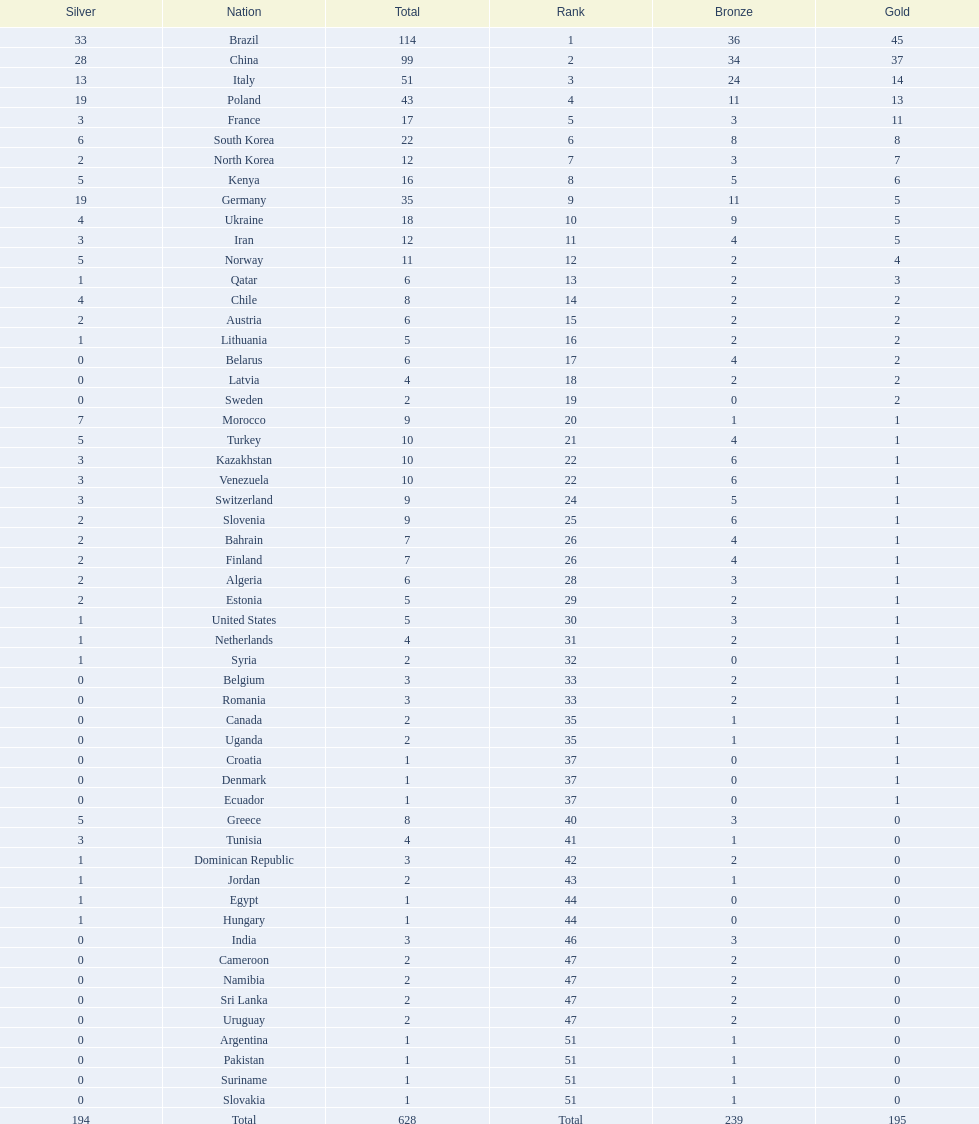Could you parse the entire table? {'header': ['Silver', 'Nation', 'Total', 'Rank', 'Bronze', 'Gold'], 'rows': [['33', 'Brazil', '114', '1', '36', '45'], ['28', 'China', '99', '2', '34', '37'], ['13', 'Italy', '51', '3', '24', '14'], ['19', 'Poland', '43', '4', '11', '13'], ['3', 'France', '17', '5', '3', '11'], ['6', 'South Korea', '22', '6', '8', '8'], ['2', 'North Korea', '12', '7', '3', '7'], ['5', 'Kenya', '16', '8', '5', '6'], ['19', 'Germany', '35', '9', '11', '5'], ['4', 'Ukraine', '18', '10', '9', '5'], ['3', 'Iran', '12', '11', '4', '5'], ['5', 'Norway', '11', '12', '2', '4'], ['1', 'Qatar', '6', '13', '2', '3'], ['4', 'Chile', '8', '14', '2', '2'], ['2', 'Austria', '6', '15', '2', '2'], ['1', 'Lithuania', '5', '16', '2', '2'], ['0', 'Belarus', '6', '17', '4', '2'], ['0', 'Latvia', '4', '18', '2', '2'], ['0', 'Sweden', '2', '19', '0', '2'], ['7', 'Morocco', '9', '20', '1', '1'], ['5', 'Turkey', '10', '21', '4', '1'], ['3', 'Kazakhstan', '10', '22', '6', '1'], ['3', 'Venezuela', '10', '22', '6', '1'], ['3', 'Switzerland', '9', '24', '5', '1'], ['2', 'Slovenia', '9', '25', '6', '1'], ['2', 'Bahrain', '7', '26', '4', '1'], ['2', 'Finland', '7', '26', '4', '1'], ['2', 'Algeria', '6', '28', '3', '1'], ['2', 'Estonia', '5', '29', '2', '1'], ['1', 'United States', '5', '30', '3', '1'], ['1', 'Netherlands', '4', '31', '2', '1'], ['1', 'Syria', '2', '32', '0', '1'], ['0', 'Belgium', '3', '33', '2', '1'], ['0', 'Romania', '3', '33', '2', '1'], ['0', 'Canada', '2', '35', '1', '1'], ['0', 'Uganda', '2', '35', '1', '1'], ['0', 'Croatia', '1', '37', '0', '1'], ['0', 'Denmark', '1', '37', '0', '1'], ['0', 'Ecuador', '1', '37', '0', '1'], ['5', 'Greece', '8', '40', '3', '0'], ['3', 'Tunisia', '4', '41', '1', '0'], ['1', 'Dominican Republic', '3', '42', '2', '0'], ['1', 'Jordan', '2', '43', '1', '0'], ['1', 'Egypt', '1', '44', '0', '0'], ['1', 'Hungary', '1', '44', '0', '0'], ['0', 'India', '3', '46', '3', '0'], ['0', 'Cameroon', '2', '47', '2', '0'], ['0', 'Namibia', '2', '47', '2', '0'], ['0', 'Sri Lanka', '2', '47', '2', '0'], ['0', 'Uruguay', '2', '47', '2', '0'], ['0', 'Argentina', '1', '51', '1', '0'], ['0', 'Pakistan', '1', '51', '1', '0'], ['0', 'Suriname', '1', '51', '1', '0'], ['0', 'Slovakia', '1', '51', '1', '0'], ['194', 'Total', '628', 'Total', '239', '195']]} What is the difference in the number of medals between south korea and north korea? 10. 